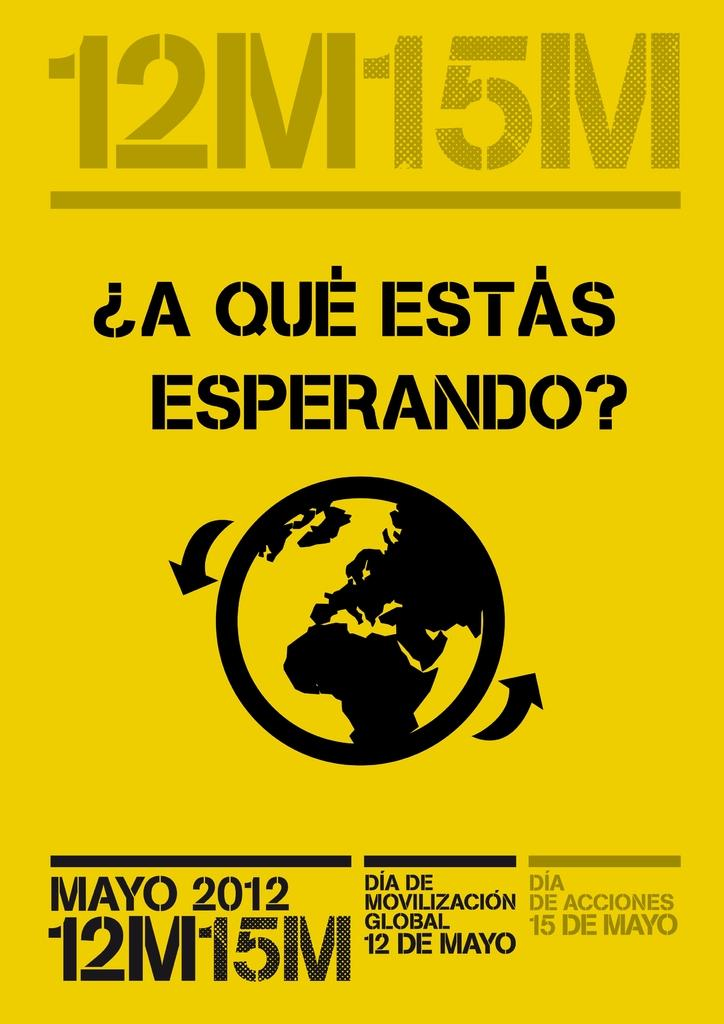<image>
Present a compact description of the photo's key features. A poster advertises 12 de Mayo for the year 2012. 